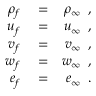<formula> <loc_0><loc_0><loc_500><loc_500>\begin{array} { r l r } { \rho _ { f } } & = } & { \rho _ { \infty } \, , } \\ { u _ { f } } & = } & { u _ { \infty } \, , } \\ { v _ { f } } & = } & { v _ { \infty } \, , } \\ { w _ { f } } & = } & { w _ { \infty } \, , } \\ { e _ { f } } & = } & { e _ { \infty } \, . } \end{array}</formula> 